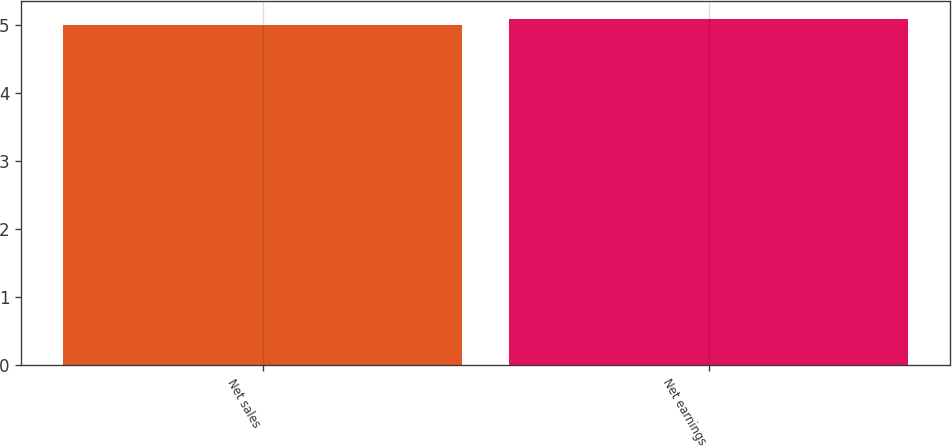<chart> <loc_0><loc_0><loc_500><loc_500><bar_chart><fcel>Net sales<fcel>Net earnings<nl><fcel>5<fcel>5.1<nl></chart> 